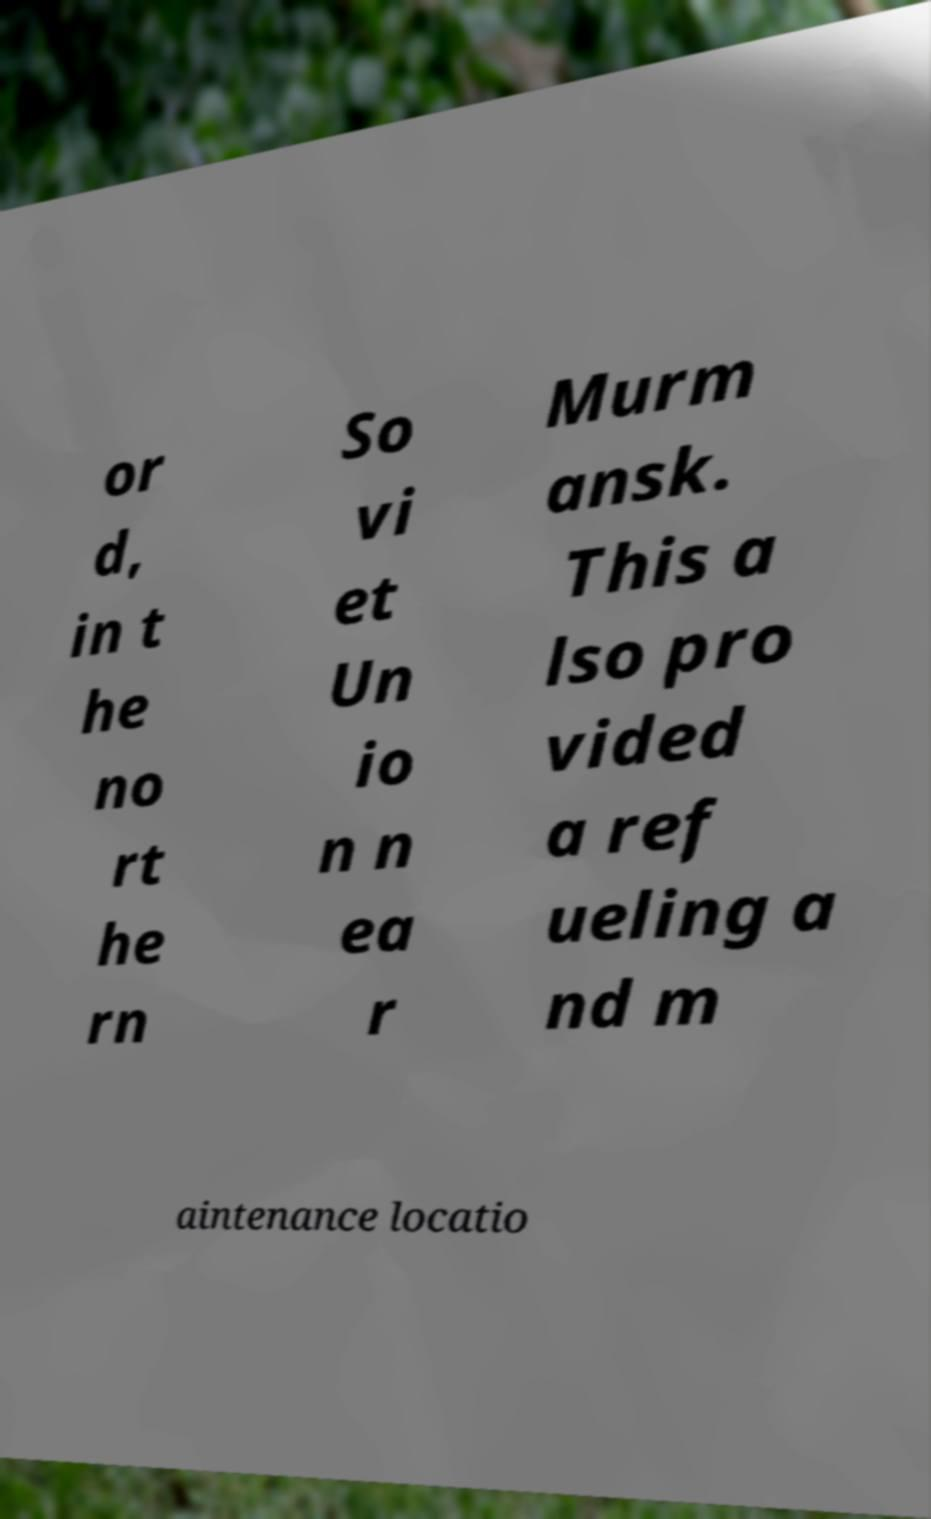Please read and relay the text visible in this image. What does it say? or d, in t he no rt he rn So vi et Un io n n ea r Murm ansk. This a lso pro vided a ref ueling a nd m aintenance locatio 